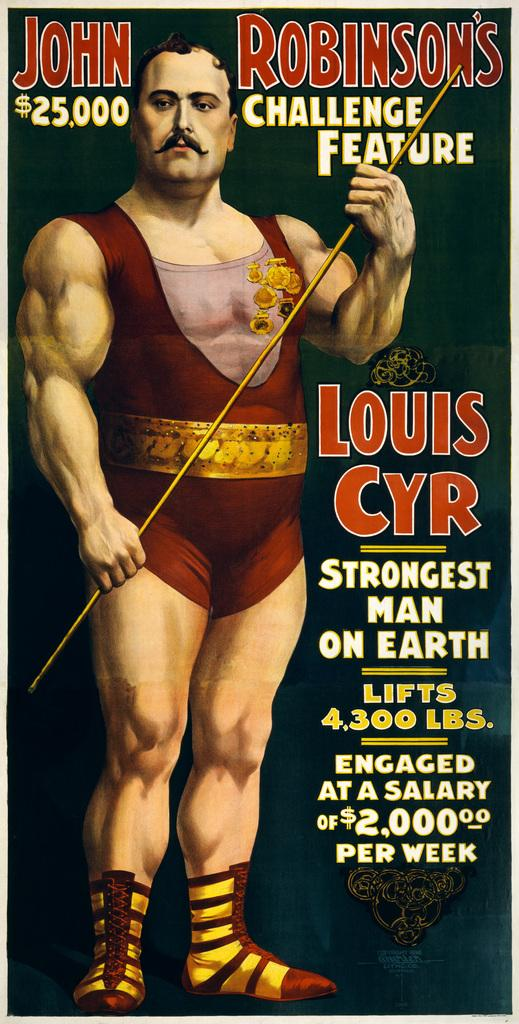What type of object is visible in the image? There is an object in the image that appears to be a poster. What can be found on the poster? The poster contains text and numbers. Is there any image on the poster? Yes, there is a picture of a man on the poster. What is the man in the picture doing? The man in the picture is standing and holding an object. How many chairs are visible in the image? There are no chairs visible in the image; it features a poster with a picture of a man. What type of trouble is the man in the picture experiencing? There is no indication of trouble in the image; the man is simply standing and holding an object. 